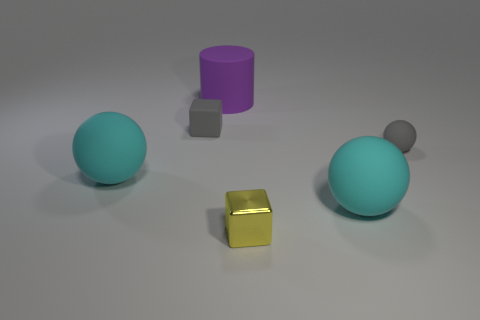Subtract all blue cylinders. How many cyan balls are left? 2 Subtract 1 spheres. How many spheres are left? 2 Add 2 gray cubes. How many objects exist? 8 Subtract all cylinders. How many objects are left? 5 Add 6 tiny matte balls. How many tiny matte balls are left? 7 Add 5 matte balls. How many matte balls exist? 8 Subtract 1 gray spheres. How many objects are left? 5 Subtract all cyan metallic objects. Subtract all cubes. How many objects are left? 4 